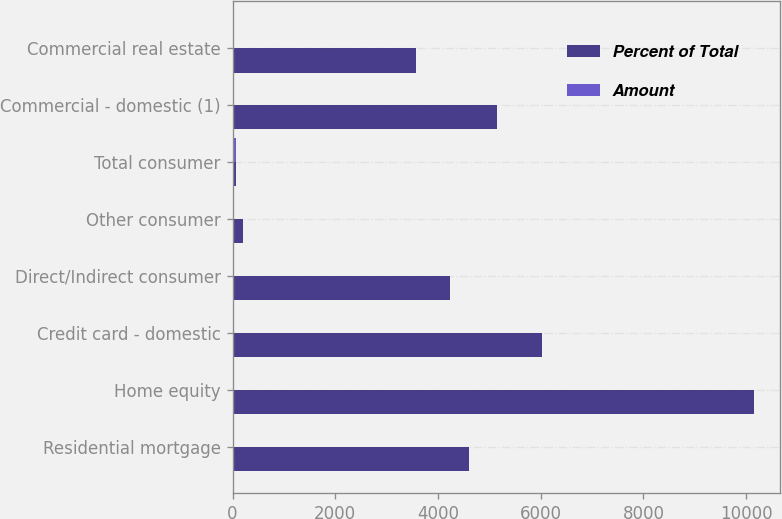<chart> <loc_0><loc_0><loc_500><loc_500><stacked_bar_chart><ecel><fcel>Residential mortgage<fcel>Home equity<fcel>Credit card - domestic<fcel>Direct/Indirect consumer<fcel>Other consumer<fcel>Total consumer<fcel>Commercial - domestic (1)<fcel>Commercial real estate<nl><fcel>Percent of Total<fcel>4607<fcel>10160<fcel>6017<fcel>4227<fcel>204<fcel>74.69<fcel>5152<fcel>3567<nl><fcel>Amount<fcel>12.38<fcel>27.31<fcel>16.18<fcel>11.36<fcel>0.55<fcel>74.69<fcel>13.85<fcel>9.59<nl></chart> 